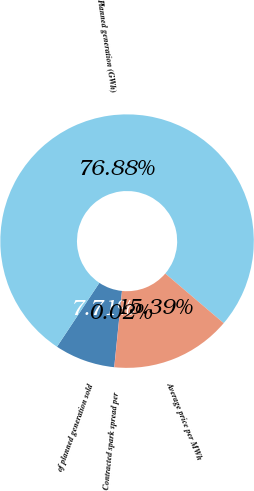Convert chart. <chart><loc_0><loc_0><loc_500><loc_500><pie_chart><fcel>of planned generation sold<fcel>Planned generation (GWh)<fcel>Average price per MWh<fcel>Contracted spark spread per<nl><fcel>7.71%<fcel>76.88%<fcel>15.39%<fcel>0.02%<nl></chart> 